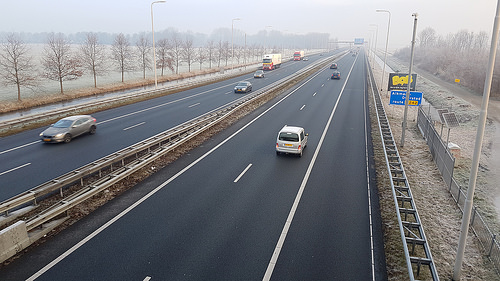<image>
Can you confirm if the road is under the car? Yes. The road is positioned underneath the car, with the car above it in the vertical space. Where is the vehicle in relation to the road? Is it next to the road? No. The vehicle is not positioned next to the road. They are located in different areas of the scene. 